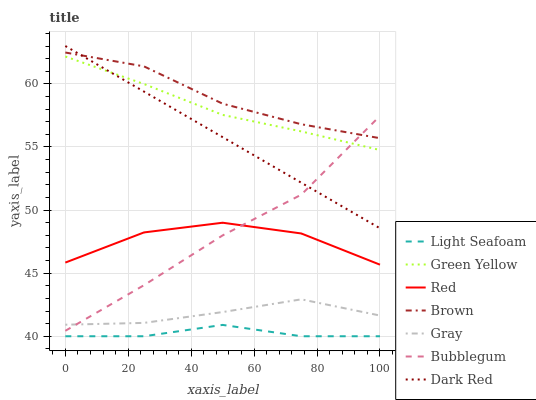Does Light Seafoam have the minimum area under the curve?
Answer yes or no. Yes. Does Brown have the maximum area under the curve?
Answer yes or no. Yes. Does Gray have the minimum area under the curve?
Answer yes or no. No. Does Gray have the maximum area under the curve?
Answer yes or no. No. Is Dark Red the smoothest?
Answer yes or no. Yes. Is Red the roughest?
Answer yes or no. Yes. Is Light Seafoam the smoothest?
Answer yes or no. No. Is Light Seafoam the roughest?
Answer yes or no. No. Does Light Seafoam have the lowest value?
Answer yes or no. Yes. Does Gray have the lowest value?
Answer yes or no. No. Does Dark Red have the highest value?
Answer yes or no. Yes. Does Gray have the highest value?
Answer yes or no. No. Is Light Seafoam less than Bubblegum?
Answer yes or no. Yes. Is Bubblegum greater than Light Seafoam?
Answer yes or no. Yes. Does Bubblegum intersect Red?
Answer yes or no. Yes. Is Bubblegum less than Red?
Answer yes or no. No. Is Bubblegum greater than Red?
Answer yes or no. No. Does Light Seafoam intersect Bubblegum?
Answer yes or no. No. 